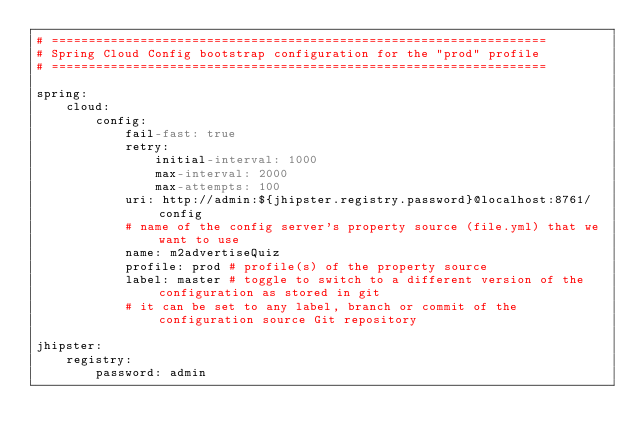<code> <loc_0><loc_0><loc_500><loc_500><_YAML_># ===================================================================
# Spring Cloud Config bootstrap configuration for the "prod" profile
# ===================================================================

spring:
    cloud:
        config:
            fail-fast: true
            retry:
                initial-interval: 1000
                max-interval: 2000
                max-attempts: 100
            uri: http://admin:${jhipster.registry.password}@localhost:8761/config
            # name of the config server's property source (file.yml) that we want to use
            name: m2advertiseQuiz
            profile: prod # profile(s) of the property source
            label: master # toggle to switch to a different version of the configuration as stored in git
            # it can be set to any label, branch or commit of the configuration source Git repository

jhipster:
    registry:
        password: admin
</code> 